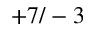<formula> <loc_0><loc_0><loc_500><loc_500>+ 7 / - 3</formula> 